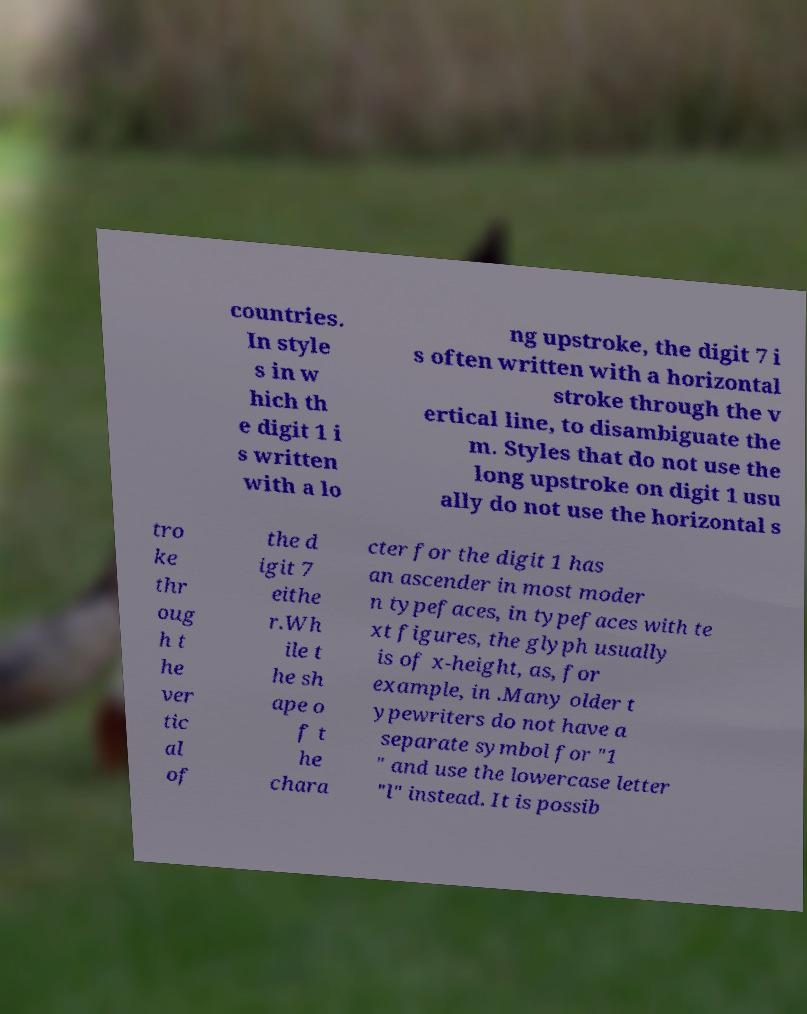Please read and relay the text visible in this image. What does it say? countries. In style s in w hich th e digit 1 i s written with a lo ng upstroke, the digit 7 i s often written with a horizontal stroke through the v ertical line, to disambiguate the m. Styles that do not use the long upstroke on digit 1 usu ally do not use the horizontal s tro ke thr oug h t he ver tic al of the d igit 7 eithe r.Wh ile t he sh ape o f t he chara cter for the digit 1 has an ascender in most moder n typefaces, in typefaces with te xt figures, the glyph usually is of x-height, as, for example, in .Many older t ypewriters do not have a separate symbol for "1 " and use the lowercase letter "l" instead. It is possib 